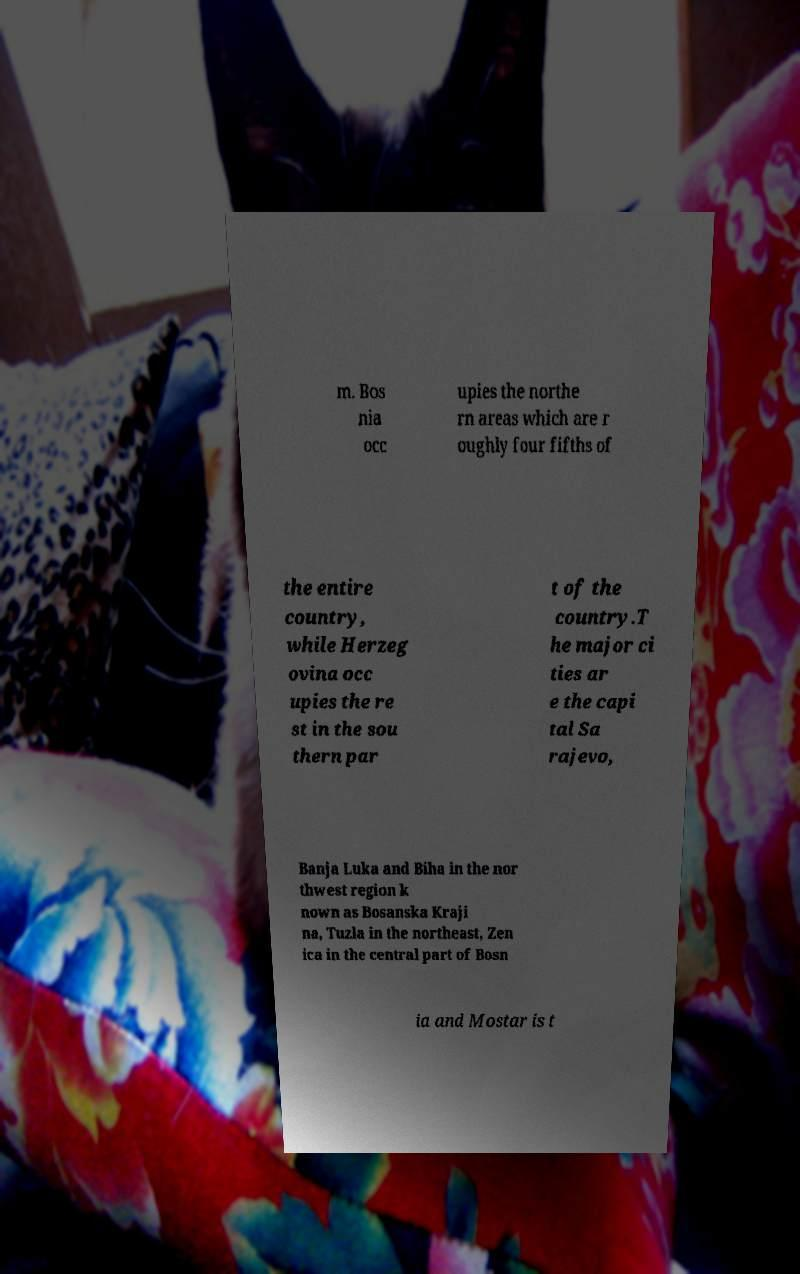Please read and relay the text visible in this image. What does it say? m. Bos nia occ upies the northe rn areas which are r oughly four fifths of the entire country, while Herzeg ovina occ upies the re st in the sou thern par t of the country.T he major ci ties ar e the capi tal Sa rajevo, Banja Luka and Biha in the nor thwest region k nown as Bosanska Kraji na, Tuzla in the northeast, Zen ica in the central part of Bosn ia and Mostar is t 